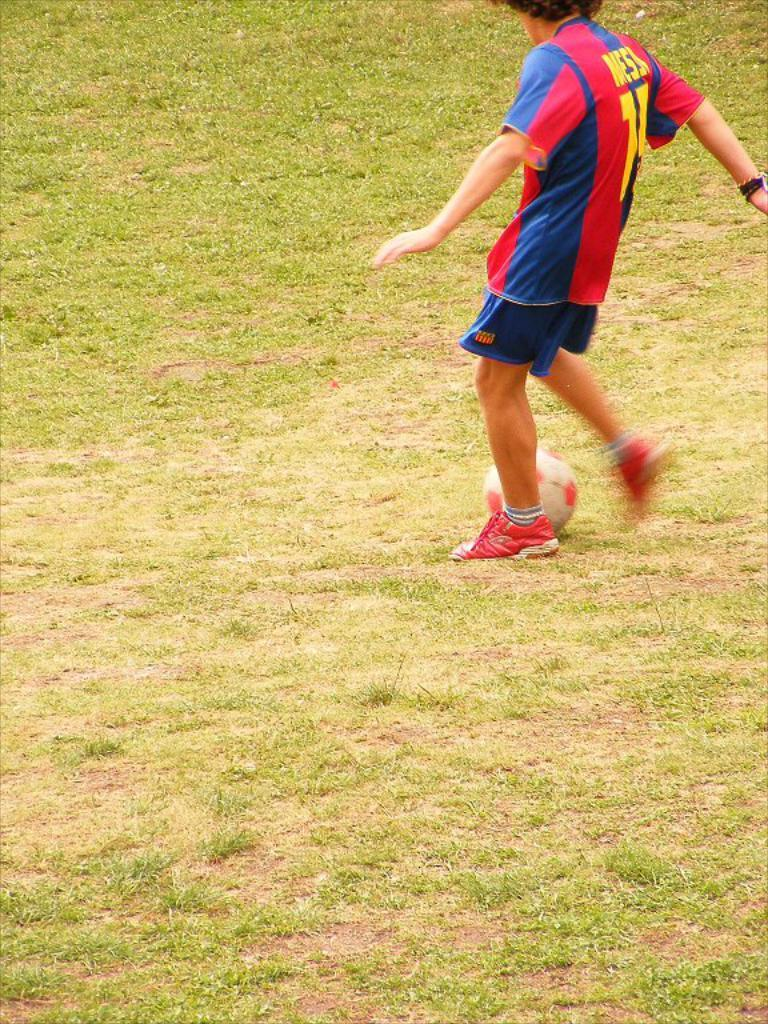<image>
Provide a brief description of the given image. A soccer player in a red and blue jersey with the letters "MESS" visible 